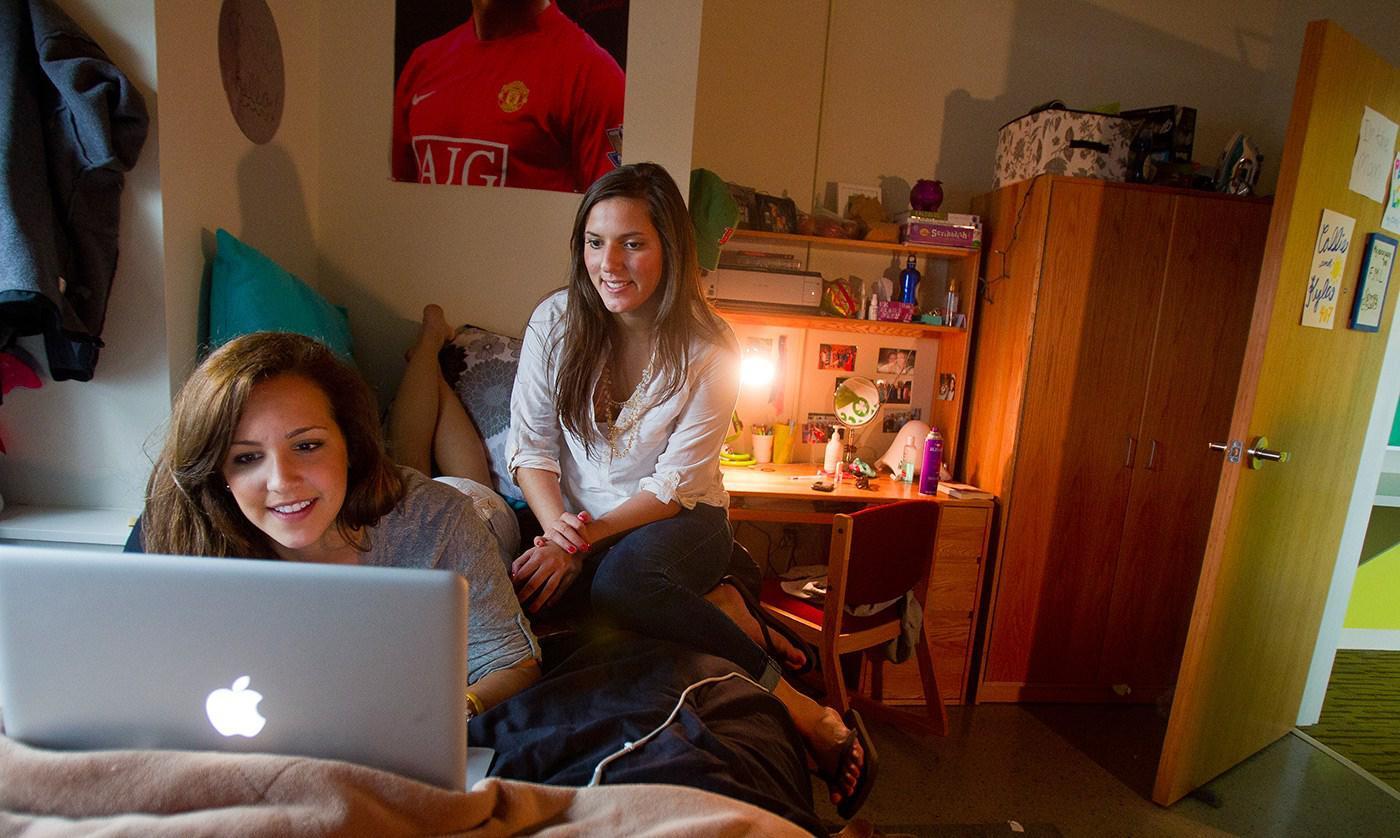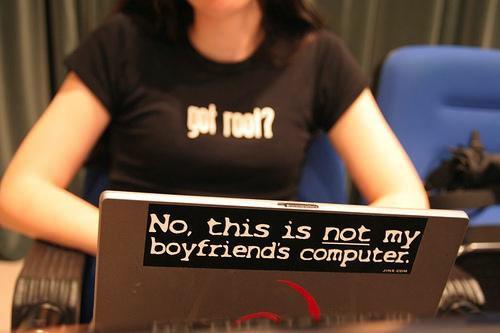The first image is the image on the left, the second image is the image on the right. Examine the images to the left and right. Is the description "An image shows one man looking at an open laptop witth his feet propped up." accurate? Answer yes or no. No. The first image is the image on the left, the second image is the image on the right. For the images displayed, is the sentence "In the image to the left, we can see exactly one guy; his upper body and face are quite visible and are obvious targets of the image." factually correct? Answer yes or no. No. 